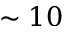Convert formula to latex. <formula><loc_0><loc_0><loc_500><loc_500>\sim 1 0</formula> 